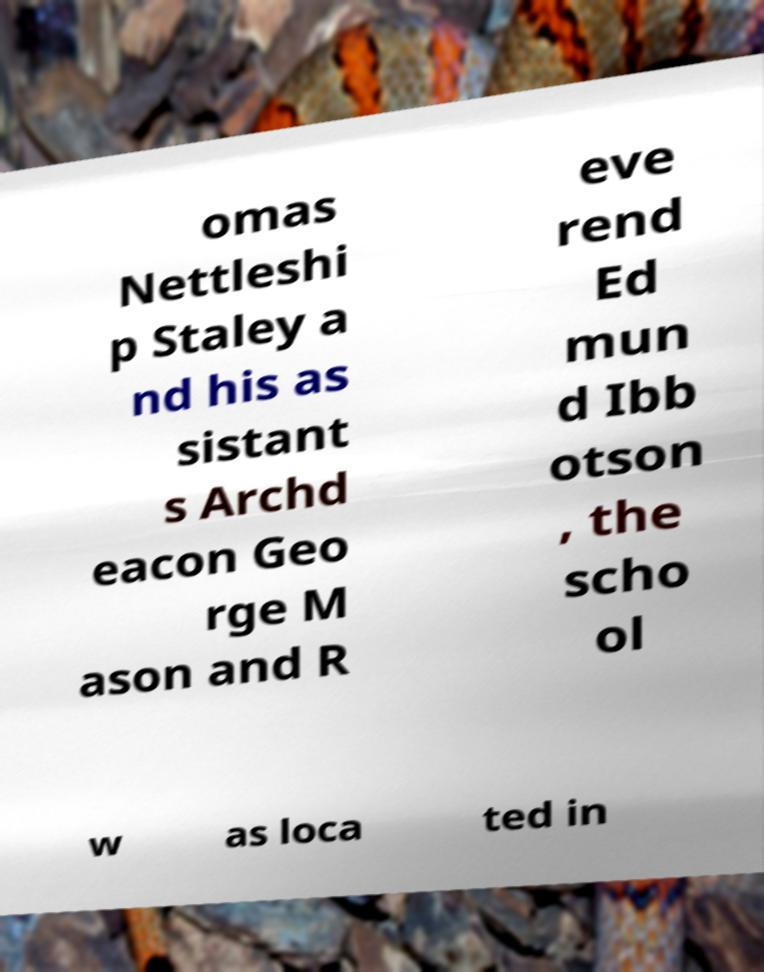Can you read and provide the text displayed in the image?This photo seems to have some interesting text. Can you extract and type it out for me? omas Nettleshi p Staley a nd his as sistant s Archd eacon Geo rge M ason and R eve rend Ed mun d Ibb otson , the scho ol w as loca ted in 